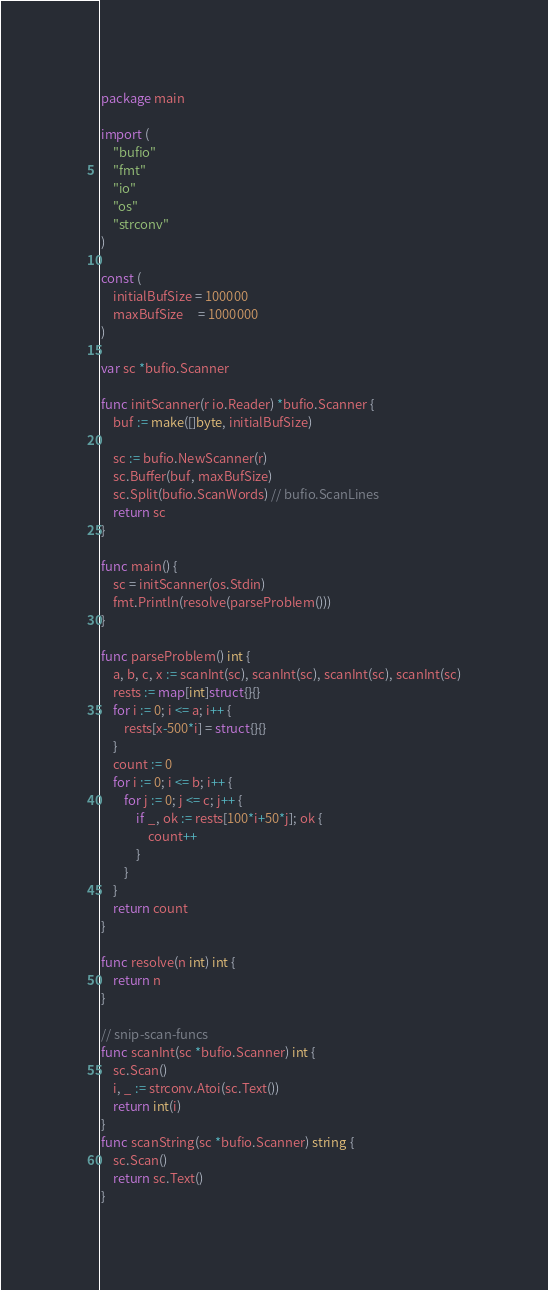<code> <loc_0><loc_0><loc_500><loc_500><_Go_>package main

import (
	"bufio"
	"fmt"
	"io"
	"os"
	"strconv"
)

const (
	initialBufSize = 100000
	maxBufSize     = 1000000
)

var sc *bufio.Scanner

func initScanner(r io.Reader) *bufio.Scanner {
	buf := make([]byte, initialBufSize)

	sc := bufio.NewScanner(r)
	sc.Buffer(buf, maxBufSize)
	sc.Split(bufio.ScanWords) // bufio.ScanLines
	return sc
}

func main() {
	sc = initScanner(os.Stdin)
	fmt.Println(resolve(parseProblem()))
}

func parseProblem() int {
	a, b, c, x := scanInt(sc), scanInt(sc), scanInt(sc), scanInt(sc)
	rests := map[int]struct{}{}
	for i := 0; i <= a; i++ {
		rests[x-500*i] = struct{}{}
	}
	count := 0
	for i := 0; i <= b; i++ {
		for j := 0; j <= c; j++ {
			if _, ok := rests[100*i+50*j]; ok {
				count++
			}
		}
	}
	return count
}

func resolve(n int) int {
	return n
}

// snip-scan-funcs
func scanInt(sc *bufio.Scanner) int {
	sc.Scan()
	i, _ := strconv.Atoi(sc.Text())
	return int(i)
}
func scanString(sc *bufio.Scanner) string {
	sc.Scan()
	return sc.Text()
}</code> 